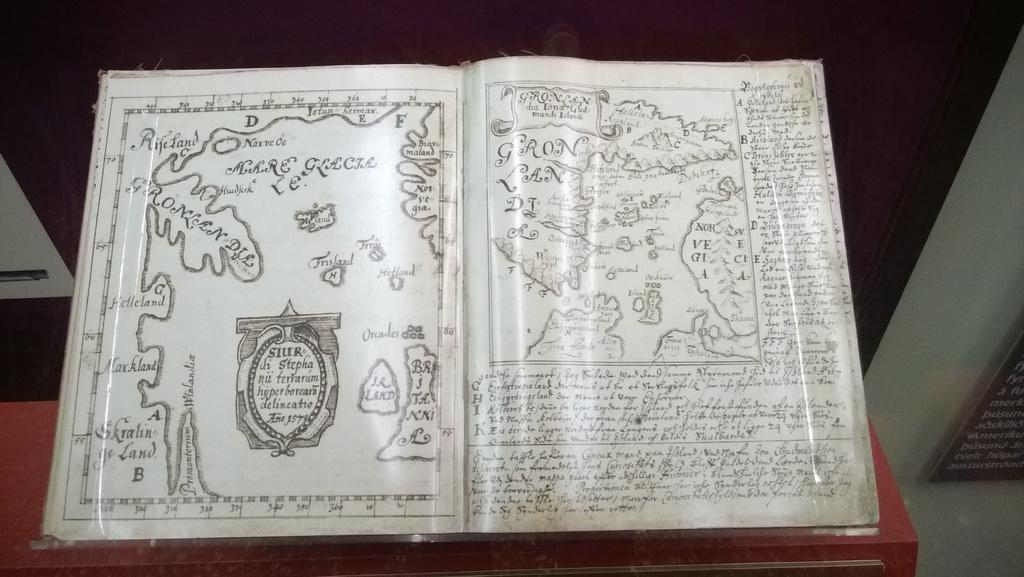What is present in the image? There is a book in the image. What type of content does the book contain? The book contains pictures and text. How many girls are undergoing an operation in the image? There are no girls or operations present in the image; it only features a book with pictures and text. 